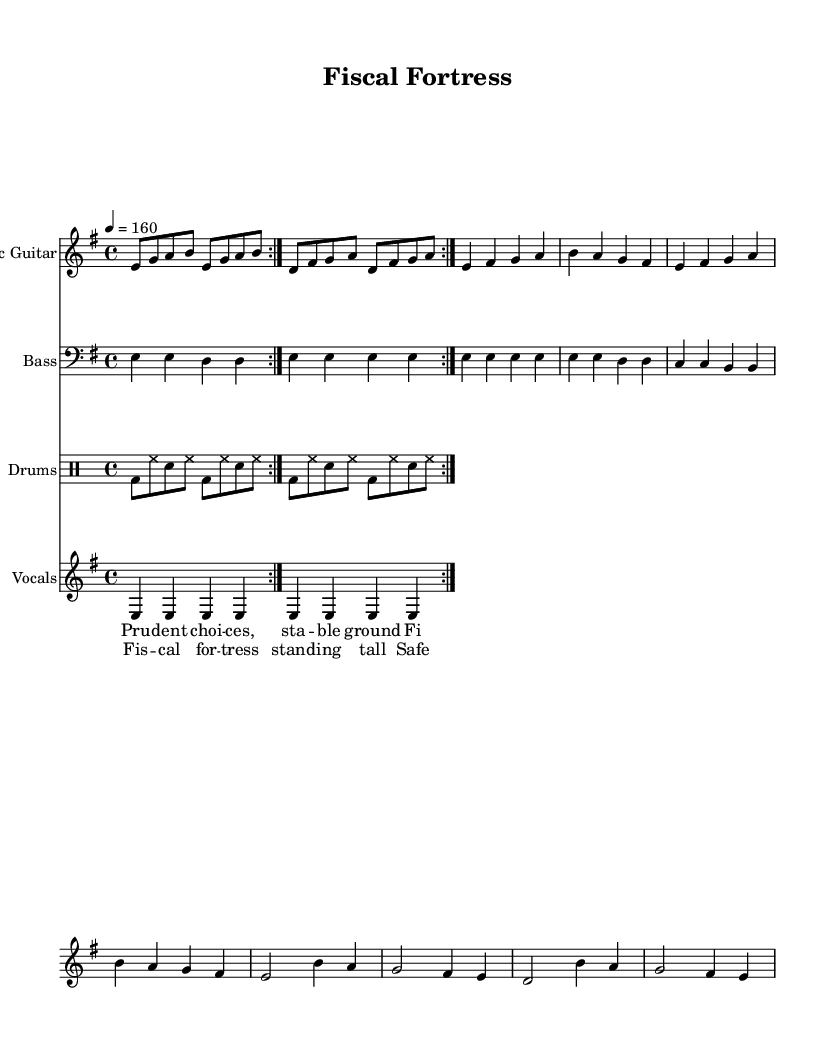What is the key signature of this music? The key signature is indicated at the beginning of the staff. It shows one sharp which corresponds to E minor.
Answer: E minor What is the time signature of this piece? The time signature is displayed at the beginning of the sheet music, which indicates there are 4 beats in each measure.
Answer: 4/4 What is the tempo marking for this piece? The tempo is indicated in the header and states the beats per minute. Here, it is set at a speed of 160 beats per minute.
Answer: 160 How many volta repetitions are there in the main riff? The notation shows a repeat section with the "volta" marking, indicating that this section should be played twice.
Answer: 2 In which section do the lyrics "Fiscal fortress standing tall" appear? By examining the layout, the captured lyrics are placed under the chorus section, indicating where these specific lines occur.
Answer: Chorus How does the bass guitar part compare to the electric guitar part in the verse? The bass guitar part plays sustained notes while the electric guitar plays a melodic line, creating a contrast in texture during the verse.
Answer: Sustained vs melodic What thematic element do the lyrics emphasize in this metal song? The lyrics focus on the themes of financial wisdom and economic stability, highlighting personal finance as a key message.
Answer: Economic stability 